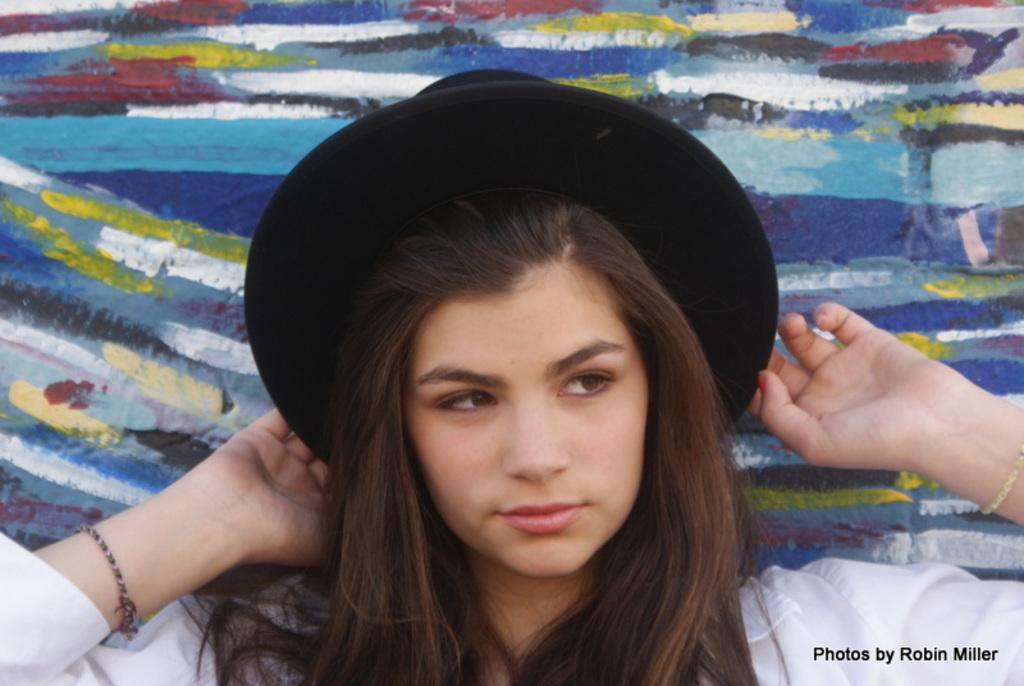Who or what is present in the image? There is a person in the image. What is the person wearing on their head? The person is wearing a hat. What else can be seen on the image besides the person? There is text on the image. How would you describe the background of the image? The background of the image has different colors. How many hands does the yak have in the image? There is no yak present in the image, so it is not possible to determine the number of hands it might have. 